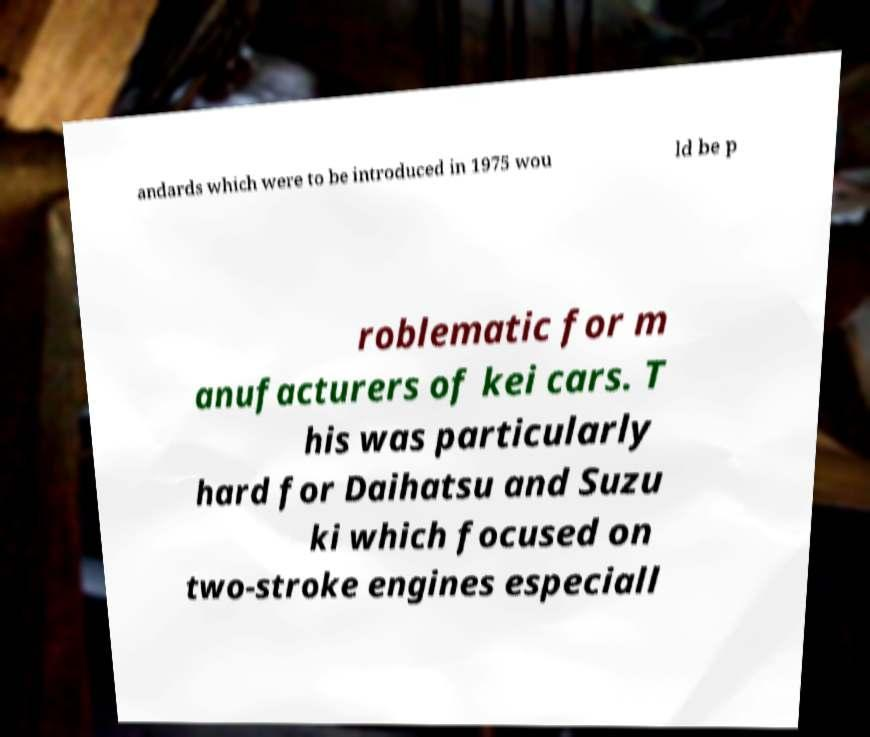Please identify and transcribe the text found in this image. andards which were to be introduced in 1975 wou ld be p roblematic for m anufacturers of kei cars. T his was particularly hard for Daihatsu and Suzu ki which focused on two-stroke engines especiall 